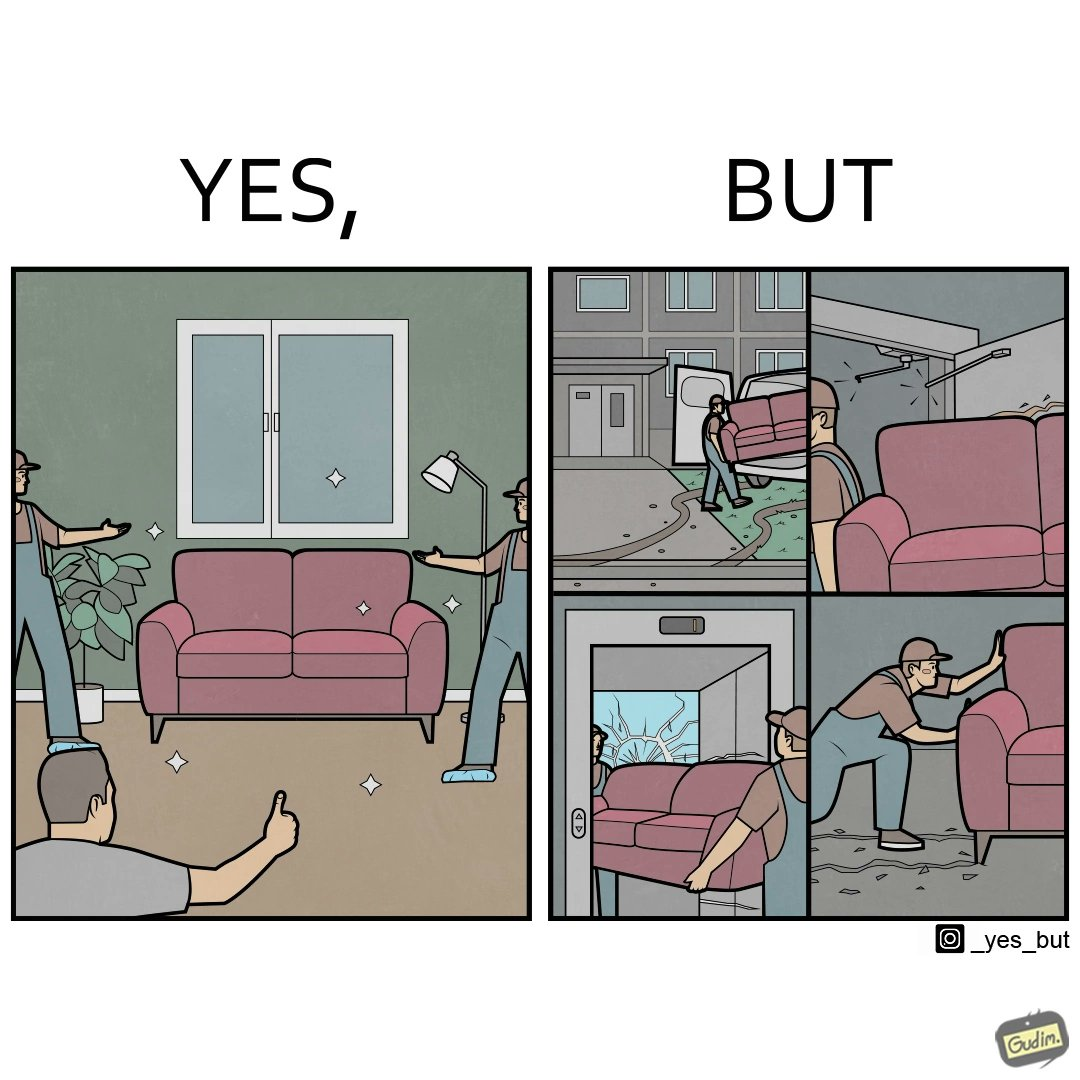Describe the content of this image. The images are funny since they show how even though the hired movers achieve their task of moving in furniture, in the process, the cause damage to the whole house 